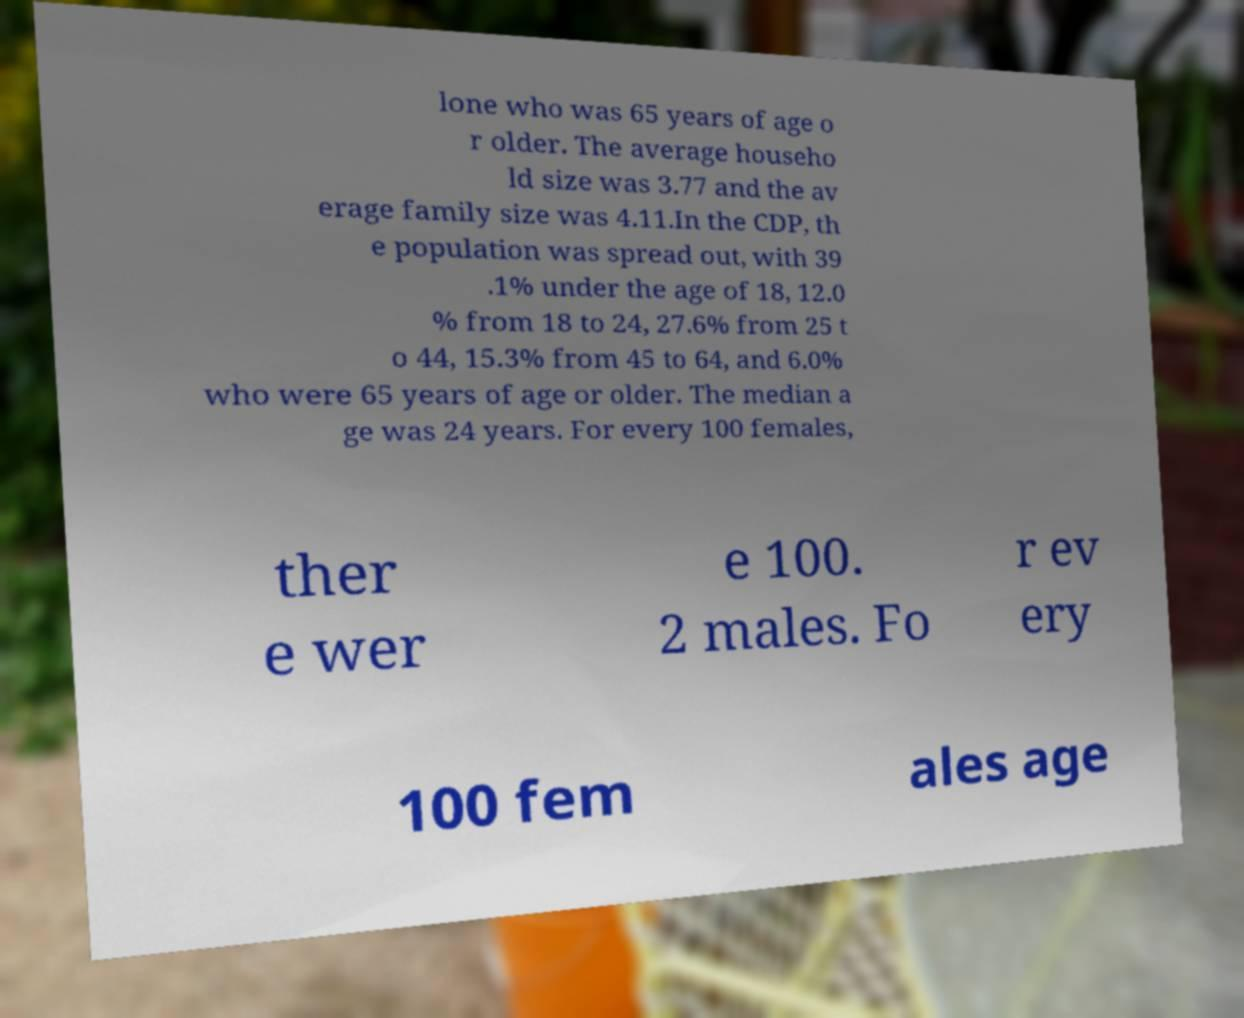Could you extract and type out the text from this image? lone who was 65 years of age o r older. The average househo ld size was 3.77 and the av erage family size was 4.11.In the CDP, th e population was spread out, with 39 .1% under the age of 18, 12.0 % from 18 to 24, 27.6% from 25 t o 44, 15.3% from 45 to 64, and 6.0% who were 65 years of age or older. The median a ge was 24 years. For every 100 females, ther e wer e 100. 2 males. Fo r ev ery 100 fem ales age 